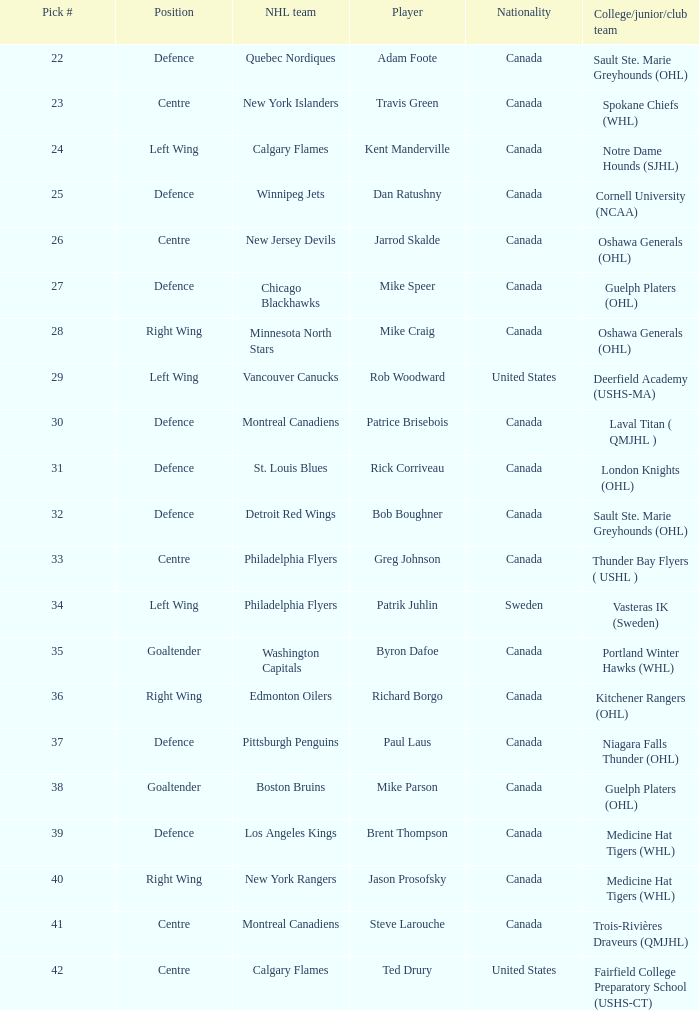What NHL team picked richard borgo? Edmonton Oilers. 